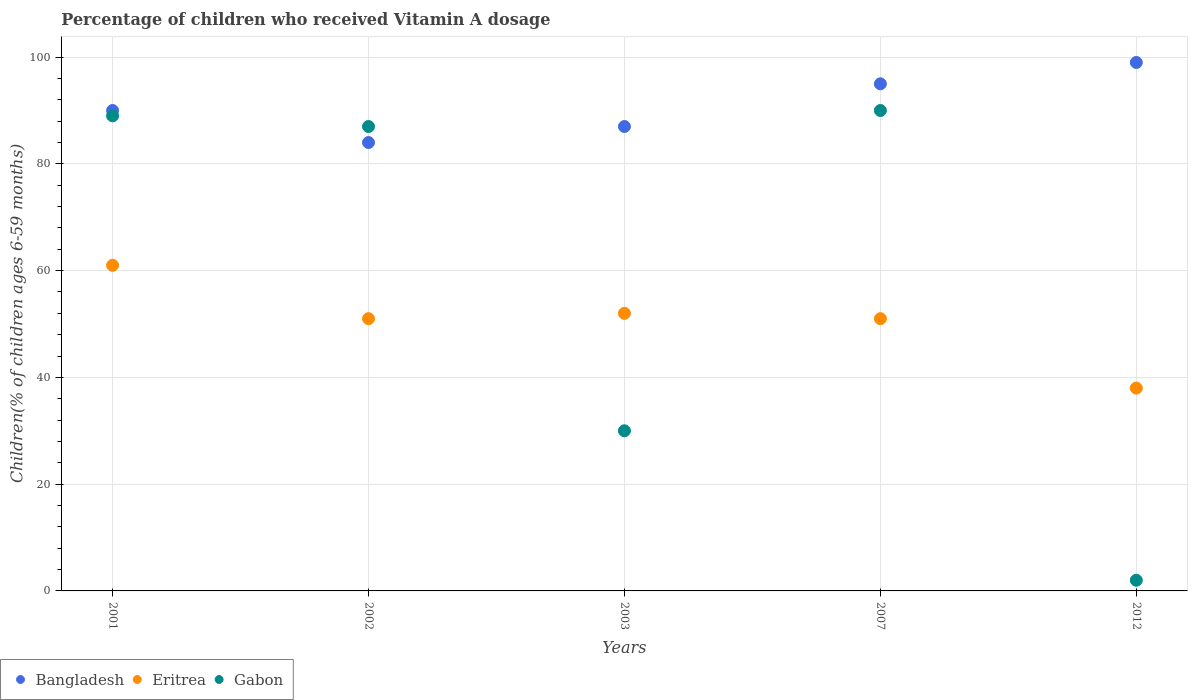How many different coloured dotlines are there?
Your response must be concise. 3. What is the percentage of children who received Vitamin A dosage in Gabon in 2001?
Give a very brief answer. 89. Across all years, what is the minimum percentage of children who received Vitamin A dosage in Gabon?
Give a very brief answer. 2. In which year was the percentage of children who received Vitamin A dosage in Bangladesh maximum?
Make the answer very short. 2012. What is the total percentage of children who received Vitamin A dosage in Eritrea in the graph?
Offer a very short reply. 253. What is the difference between the percentage of children who received Vitamin A dosage in Bangladesh in 2002 and that in 2012?
Provide a short and direct response. -15. What is the difference between the percentage of children who received Vitamin A dosage in Eritrea in 2003 and the percentage of children who received Vitamin A dosage in Bangladesh in 2007?
Your response must be concise. -43. What is the average percentage of children who received Vitamin A dosage in Eritrea per year?
Offer a terse response. 50.6. In the year 2012, what is the difference between the percentage of children who received Vitamin A dosage in Gabon and percentage of children who received Vitamin A dosage in Bangladesh?
Your response must be concise. -97. In how many years, is the percentage of children who received Vitamin A dosage in Bangladesh greater than 72 %?
Offer a very short reply. 5. What is the ratio of the percentage of children who received Vitamin A dosage in Bangladesh in 2001 to that in 2007?
Your answer should be very brief. 0.95. Is the difference between the percentage of children who received Vitamin A dosage in Gabon in 2001 and 2012 greater than the difference between the percentage of children who received Vitamin A dosage in Bangladesh in 2001 and 2012?
Keep it short and to the point. Yes. What is the difference between the highest and the second highest percentage of children who received Vitamin A dosage in Eritrea?
Provide a short and direct response. 9. What is the difference between the highest and the lowest percentage of children who received Vitamin A dosage in Eritrea?
Your response must be concise. 23. In how many years, is the percentage of children who received Vitamin A dosage in Gabon greater than the average percentage of children who received Vitamin A dosage in Gabon taken over all years?
Your answer should be compact. 3. Is the sum of the percentage of children who received Vitamin A dosage in Bangladesh in 2001 and 2003 greater than the maximum percentage of children who received Vitamin A dosage in Eritrea across all years?
Provide a succinct answer. Yes. Is the percentage of children who received Vitamin A dosage in Bangladesh strictly less than the percentage of children who received Vitamin A dosage in Gabon over the years?
Give a very brief answer. No. How many years are there in the graph?
Provide a succinct answer. 5. What is the difference between two consecutive major ticks on the Y-axis?
Offer a very short reply. 20. Are the values on the major ticks of Y-axis written in scientific E-notation?
Provide a short and direct response. No. Where does the legend appear in the graph?
Make the answer very short. Bottom left. How are the legend labels stacked?
Your response must be concise. Horizontal. What is the title of the graph?
Give a very brief answer. Percentage of children who received Vitamin A dosage. Does "Finland" appear as one of the legend labels in the graph?
Keep it short and to the point. No. What is the label or title of the Y-axis?
Your answer should be compact. Children(% of children ages 6-59 months). What is the Children(% of children ages 6-59 months) of Gabon in 2001?
Make the answer very short. 89. What is the Children(% of children ages 6-59 months) of Bangladesh in 2002?
Keep it short and to the point. 84. What is the Children(% of children ages 6-59 months) in Gabon in 2002?
Keep it short and to the point. 87. What is the Children(% of children ages 6-59 months) in Gabon in 2007?
Provide a short and direct response. 90. What is the Children(% of children ages 6-59 months) of Bangladesh in 2012?
Your answer should be very brief. 99. What is the Children(% of children ages 6-59 months) in Gabon in 2012?
Provide a short and direct response. 2. Across all years, what is the maximum Children(% of children ages 6-59 months) in Eritrea?
Your response must be concise. 61. Across all years, what is the maximum Children(% of children ages 6-59 months) of Gabon?
Ensure brevity in your answer.  90. What is the total Children(% of children ages 6-59 months) in Bangladesh in the graph?
Your answer should be very brief. 455. What is the total Children(% of children ages 6-59 months) in Eritrea in the graph?
Your answer should be compact. 253. What is the total Children(% of children ages 6-59 months) of Gabon in the graph?
Your answer should be compact. 298. What is the difference between the Children(% of children ages 6-59 months) in Bangladesh in 2001 and that in 2002?
Make the answer very short. 6. What is the difference between the Children(% of children ages 6-59 months) of Gabon in 2001 and that in 2002?
Keep it short and to the point. 2. What is the difference between the Children(% of children ages 6-59 months) of Gabon in 2001 and that in 2003?
Provide a short and direct response. 59. What is the difference between the Children(% of children ages 6-59 months) of Gabon in 2001 and that in 2012?
Provide a succinct answer. 87. What is the difference between the Children(% of children ages 6-59 months) of Bangladesh in 2002 and that in 2007?
Provide a succinct answer. -11. What is the difference between the Children(% of children ages 6-59 months) in Gabon in 2003 and that in 2007?
Make the answer very short. -60. What is the difference between the Children(% of children ages 6-59 months) of Gabon in 2007 and that in 2012?
Offer a very short reply. 88. What is the difference between the Children(% of children ages 6-59 months) of Bangladesh in 2001 and the Children(% of children ages 6-59 months) of Gabon in 2002?
Keep it short and to the point. 3. What is the difference between the Children(% of children ages 6-59 months) of Eritrea in 2001 and the Children(% of children ages 6-59 months) of Gabon in 2003?
Offer a terse response. 31. What is the difference between the Children(% of children ages 6-59 months) of Bangladesh in 2001 and the Children(% of children ages 6-59 months) of Eritrea in 2007?
Keep it short and to the point. 39. What is the difference between the Children(% of children ages 6-59 months) in Bangladesh in 2001 and the Children(% of children ages 6-59 months) in Gabon in 2007?
Offer a very short reply. 0. What is the difference between the Children(% of children ages 6-59 months) of Bangladesh in 2001 and the Children(% of children ages 6-59 months) of Gabon in 2012?
Provide a succinct answer. 88. What is the difference between the Children(% of children ages 6-59 months) in Bangladesh in 2002 and the Children(% of children ages 6-59 months) in Eritrea in 2003?
Give a very brief answer. 32. What is the difference between the Children(% of children ages 6-59 months) of Bangladesh in 2002 and the Children(% of children ages 6-59 months) of Gabon in 2003?
Keep it short and to the point. 54. What is the difference between the Children(% of children ages 6-59 months) in Eritrea in 2002 and the Children(% of children ages 6-59 months) in Gabon in 2003?
Your response must be concise. 21. What is the difference between the Children(% of children ages 6-59 months) of Bangladesh in 2002 and the Children(% of children ages 6-59 months) of Eritrea in 2007?
Offer a terse response. 33. What is the difference between the Children(% of children ages 6-59 months) in Eritrea in 2002 and the Children(% of children ages 6-59 months) in Gabon in 2007?
Provide a succinct answer. -39. What is the difference between the Children(% of children ages 6-59 months) in Eritrea in 2002 and the Children(% of children ages 6-59 months) in Gabon in 2012?
Provide a short and direct response. 49. What is the difference between the Children(% of children ages 6-59 months) of Bangladesh in 2003 and the Children(% of children ages 6-59 months) of Eritrea in 2007?
Keep it short and to the point. 36. What is the difference between the Children(% of children ages 6-59 months) in Bangladesh in 2003 and the Children(% of children ages 6-59 months) in Gabon in 2007?
Offer a terse response. -3. What is the difference between the Children(% of children ages 6-59 months) of Eritrea in 2003 and the Children(% of children ages 6-59 months) of Gabon in 2007?
Ensure brevity in your answer.  -38. What is the difference between the Children(% of children ages 6-59 months) of Eritrea in 2003 and the Children(% of children ages 6-59 months) of Gabon in 2012?
Offer a very short reply. 50. What is the difference between the Children(% of children ages 6-59 months) in Bangladesh in 2007 and the Children(% of children ages 6-59 months) in Eritrea in 2012?
Give a very brief answer. 57. What is the difference between the Children(% of children ages 6-59 months) of Bangladesh in 2007 and the Children(% of children ages 6-59 months) of Gabon in 2012?
Provide a succinct answer. 93. What is the difference between the Children(% of children ages 6-59 months) of Eritrea in 2007 and the Children(% of children ages 6-59 months) of Gabon in 2012?
Make the answer very short. 49. What is the average Children(% of children ages 6-59 months) of Bangladesh per year?
Provide a short and direct response. 91. What is the average Children(% of children ages 6-59 months) of Eritrea per year?
Give a very brief answer. 50.6. What is the average Children(% of children ages 6-59 months) in Gabon per year?
Provide a succinct answer. 59.6. In the year 2001, what is the difference between the Children(% of children ages 6-59 months) of Bangladesh and Children(% of children ages 6-59 months) of Gabon?
Your answer should be compact. 1. In the year 2002, what is the difference between the Children(% of children ages 6-59 months) of Bangladesh and Children(% of children ages 6-59 months) of Eritrea?
Offer a very short reply. 33. In the year 2002, what is the difference between the Children(% of children ages 6-59 months) of Eritrea and Children(% of children ages 6-59 months) of Gabon?
Keep it short and to the point. -36. In the year 2003, what is the difference between the Children(% of children ages 6-59 months) of Bangladesh and Children(% of children ages 6-59 months) of Eritrea?
Keep it short and to the point. 35. In the year 2003, what is the difference between the Children(% of children ages 6-59 months) in Bangladesh and Children(% of children ages 6-59 months) in Gabon?
Your response must be concise. 57. In the year 2003, what is the difference between the Children(% of children ages 6-59 months) of Eritrea and Children(% of children ages 6-59 months) of Gabon?
Offer a terse response. 22. In the year 2007, what is the difference between the Children(% of children ages 6-59 months) in Bangladesh and Children(% of children ages 6-59 months) in Eritrea?
Your response must be concise. 44. In the year 2007, what is the difference between the Children(% of children ages 6-59 months) in Bangladesh and Children(% of children ages 6-59 months) in Gabon?
Provide a succinct answer. 5. In the year 2007, what is the difference between the Children(% of children ages 6-59 months) in Eritrea and Children(% of children ages 6-59 months) in Gabon?
Your answer should be very brief. -39. In the year 2012, what is the difference between the Children(% of children ages 6-59 months) in Bangladesh and Children(% of children ages 6-59 months) in Gabon?
Make the answer very short. 97. In the year 2012, what is the difference between the Children(% of children ages 6-59 months) in Eritrea and Children(% of children ages 6-59 months) in Gabon?
Offer a terse response. 36. What is the ratio of the Children(% of children ages 6-59 months) in Bangladesh in 2001 to that in 2002?
Ensure brevity in your answer.  1.07. What is the ratio of the Children(% of children ages 6-59 months) in Eritrea in 2001 to that in 2002?
Your answer should be very brief. 1.2. What is the ratio of the Children(% of children ages 6-59 months) in Gabon in 2001 to that in 2002?
Your answer should be compact. 1.02. What is the ratio of the Children(% of children ages 6-59 months) in Bangladesh in 2001 to that in 2003?
Provide a succinct answer. 1.03. What is the ratio of the Children(% of children ages 6-59 months) of Eritrea in 2001 to that in 2003?
Provide a succinct answer. 1.17. What is the ratio of the Children(% of children ages 6-59 months) of Gabon in 2001 to that in 2003?
Ensure brevity in your answer.  2.97. What is the ratio of the Children(% of children ages 6-59 months) in Eritrea in 2001 to that in 2007?
Ensure brevity in your answer.  1.2. What is the ratio of the Children(% of children ages 6-59 months) of Gabon in 2001 to that in 2007?
Provide a short and direct response. 0.99. What is the ratio of the Children(% of children ages 6-59 months) in Eritrea in 2001 to that in 2012?
Your answer should be very brief. 1.61. What is the ratio of the Children(% of children ages 6-59 months) of Gabon in 2001 to that in 2012?
Your answer should be very brief. 44.5. What is the ratio of the Children(% of children ages 6-59 months) of Bangladesh in 2002 to that in 2003?
Provide a short and direct response. 0.97. What is the ratio of the Children(% of children ages 6-59 months) of Eritrea in 2002 to that in 2003?
Your response must be concise. 0.98. What is the ratio of the Children(% of children ages 6-59 months) of Gabon in 2002 to that in 2003?
Your answer should be very brief. 2.9. What is the ratio of the Children(% of children ages 6-59 months) of Bangladesh in 2002 to that in 2007?
Provide a succinct answer. 0.88. What is the ratio of the Children(% of children ages 6-59 months) in Gabon in 2002 to that in 2007?
Provide a succinct answer. 0.97. What is the ratio of the Children(% of children ages 6-59 months) in Bangladesh in 2002 to that in 2012?
Your response must be concise. 0.85. What is the ratio of the Children(% of children ages 6-59 months) in Eritrea in 2002 to that in 2012?
Offer a very short reply. 1.34. What is the ratio of the Children(% of children ages 6-59 months) in Gabon in 2002 to that in 2012?
Keep it short and to the point. 43.5. What is the ratio of the Children(% of children ages 6-59 months) in Bangladesh in 2003 to that in 2007?
Your answer should be compact. 0.92. What is the ratio of the Children(% of children ages 6-59 months) of Eritrea in 2003 to that in 2007?
Make the answer very short. 1.02. What is the ratio of the Children(% of children ages 6-59 months) in Bangladesh in 2003 to that in 2012?
Provide a short and direct response. 0.88. What is the ratio of the Children(% of children ages 6-59 months) of Eritrea in 2003 to that in 2012?
Provide a short and direct response. 1.37. What is the ratio of the Children(% of children ages 6-59 months) of Gabon in 2003 to that in 2012?
Provide a succinct answer. 15. What is the ratio of the Children(% of children ages 6-59 months) in Bangladesh in 2007 to that in 2012?
Your answer should be very brief. 0.96. What is the ratio of the Children(% of children ages 6-59 months) in Eritrea in 2007 to that in 2012?
Provide a short and direct response. 1.34. What is the difference between the highest and the second highest Children(% of children ages 6-59 months) of Gabon?
Offer a very short reply. 1. What is the difference between the highest and the lowest Children(% of children ages 6-59 months) of Eritrea?
Give a very brief answer. 23. What is the difference between the highest and the lowest Children(% of children ages 6-59 months) of Gabon?
Keep it short and to the point. 88. 